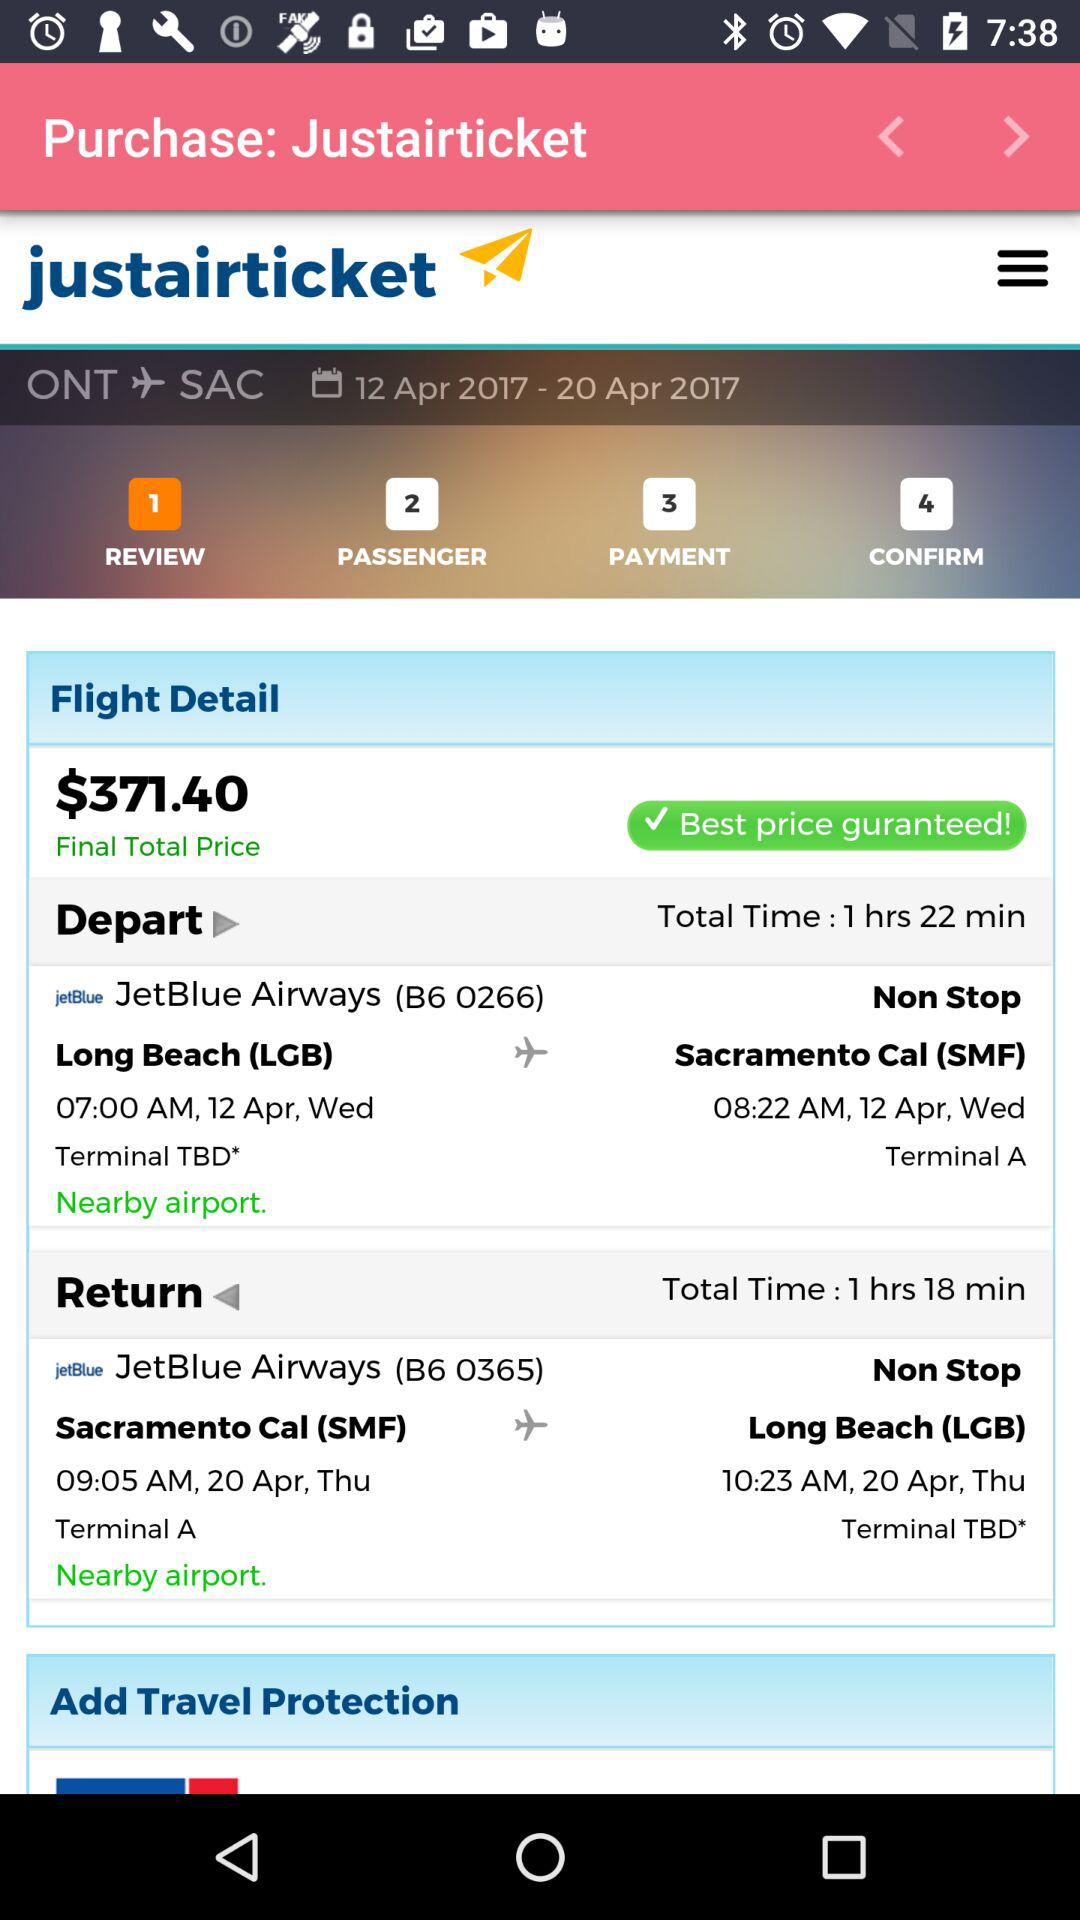How much is the total price of the flight?
Answer the question using a single word or phrase. $371.40 